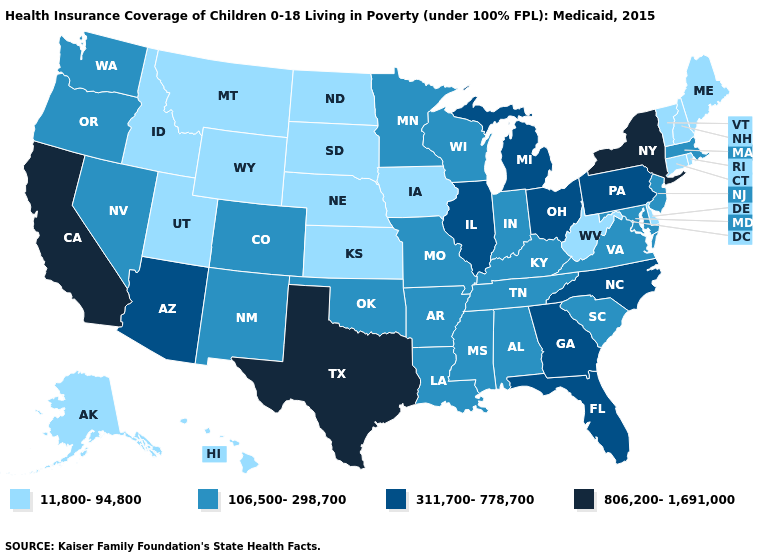Does the first symbol in the legend represent the smallest category?
Concise answer only. Yes. Among the states that border Arkansas , which have the highest value?
Be succinct. Texas. Name the states that have a value in the range 11,800-94,800?
Keep it brief. Alaska, Connecticut, Delaware, Hawaii, Idaho, Iowa, Kansas, Maine, Montana, Nebraska, New Hampshire, North Dakota, Rhode Island, South Dakota, Utah, Vermont, West Virginia, Wyoming. Name the states that have a value in the range 806,200-1,691,000?
Be succinct. California, New York, Texas. Does the first symbol in the legend represent the smallest category?
Quick response, please. Yes. What is the value of New York?
Give a very brief answer. 806,200-1,691,000. Among the states that border Utah , which have the lowest value?
Quick response, please. Idaho, Wyoming. Does Washington have a higher value than West Virginia?
Keep it brief. Yes. Which states have the lowest value in the Northeast?
Write a very short answer. Connecticut, Maine, New Hampshire, Rhode Island, Vermont. Does Delaware have the lowest value in the USA?
Write a very short answer. Yes. Does Illinois have a lower value than California?
Be succinct. Yes. Does Montana have the same value as Oregon?
Give a very brief answer. No. Among the states that border Nevada , which have the lowest value?
Be succinct. Idaho, Utah. Does New York have the highest value in the Northeast?
Short answer required. Yes. Among the states that border California , does Nevada have the highest value?
Write a very short answer. No. 